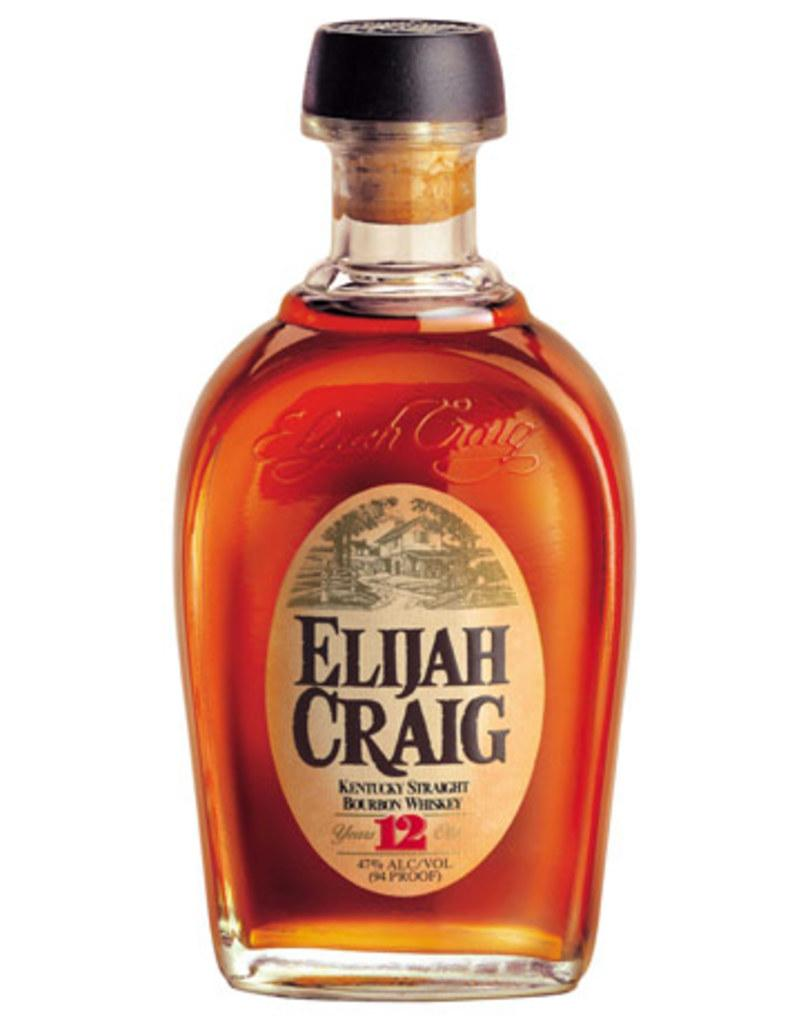<image>
Offer a succinct explanation of the picture presented. a bottle of kentucky straight bourbon whiskey named elijah craig 